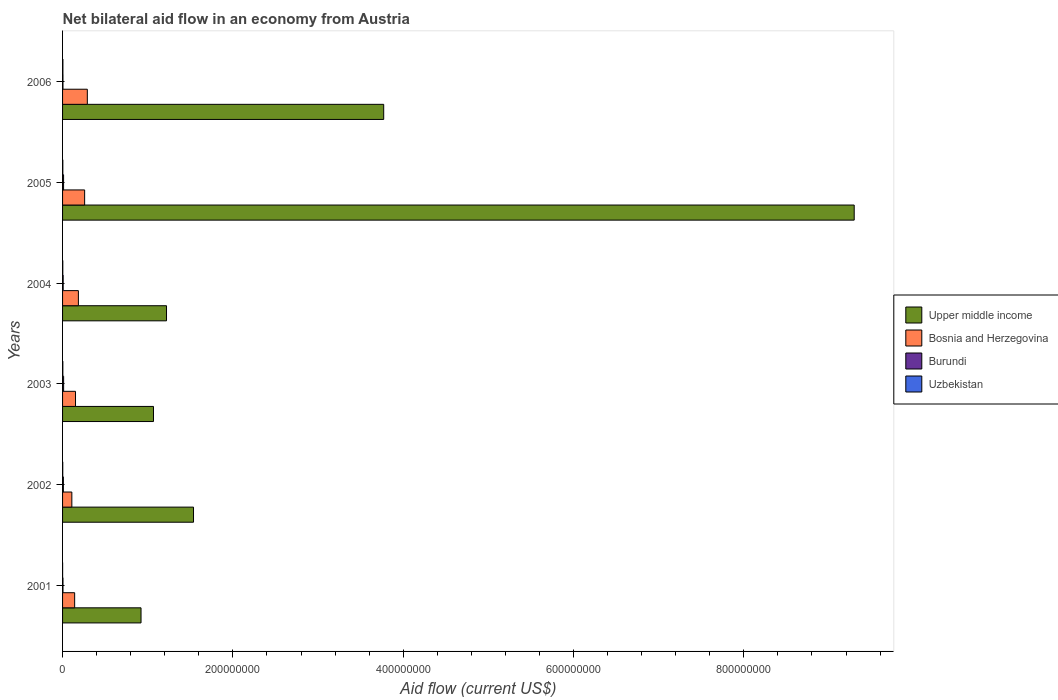How many groups of bars are there?
Make the answer very short. 6. How many bars are there on the 6th tick from the top?
Provide a succinct answer. 4. What is the label of the 6th group of bars from the top?
Offer a very short reply. 2001. In how many cases, is the number of bars for a given year not equal to the number of legend labels?
Your answer should be very brief. 0. What is the net bilateral aid flow in Upper middle income in 2002?
Offer a very short reply. 1.54e+08. Across all years, what is the maximum net bilateral aid flow in Bosnia and Herzegovina?
Your response must be concise. 2.91e+07. In which year was the net bilateral aid flow in Burundi maximum?
Ensure brevity in your answer.  2003. In which year was the net bilateral aid flow in Upper middle income minimum?
Provide a short and direct response. 2001. What is the total net bilateral aid flow in Bosnia and Herzegovina in the graph?
Your answer should be very brief. 1.14e+08. What is the difference between the net bilateral aid flow in Uzbekistan in 2004 and the net bilateral aid flow in Burundi in 2003?
Your answer should be very brief. -9.70e+05. What is the average net bilateral aid flow in Uzbekistan per year?
Ensure brevity in your answer.  2.58e+05. In the year 2002, what is the difference between the net bilateral aid flow in Uzbekistan and net bilateral aid flow in Burundi?
Make the answer very short. -7.40e+05. Is the net bilateral aid flow in Bosnia and Herzegovina in 2004 less than that in 2005?
Your answer should be compact. Yes. Is the difference between the net bilateral aid flow in Uzbekistan in 2001 and 2004 greater than the difference between the net bilateral aid flow in Burundi in 2001 and 2004?
Your answer should be very brief. Yes. What is the difference between the highest and the second highest net bilateral aid flow in Bosnia and Herzegovina?
Your answer should be very brief. 3.14e+06. What is the difference between the highest and the lowest net bilateral aid flow in Upper middle income?
Keep it short and to the point. 8.37e+08. Is the sum of the net bilateral aid flow in Upper middle income in 2002 and 2003 greater than the maximum net bilateral aid flow in Uzbekistan across all years?
Your answer should be very brief. Yes. What does the 1st bar from the top in 2005 represents?
Your answer should be compact. Uzbekistan. What does the 3rd bar from the bottom in 2005 represents?
Give a very brief answer. Burundi. Is it the case that in every year, the sum of the net bilateral aid flow in Bosnia and Herzegovina and net bilateral aid flow in Upper middle income is greater than the net bilateral aid flow in Uzbekistan?
Keep it short and to the point. Yes. How many years are there in the graph?
Make the answer very short. 6. Where does the legend appear in the graph?
Ensure brevity in your answer.  Center right. How many legend labels are there?
Your answer should be very brief. 4. What is the title of the graph?
Your answer should be very brief. Net bilateral aid flow in an economy from Austria. Does "Sudan" appear as one of the legend labels in the graph?
Provide a short and direct response. No. What is the label or title of the Y-axis?
Provide a short and direct response. Years. What is the Aid flow (current US$) in Upper middle income in 2001?
Your answer should be compact. 9.21e+07. What is the Aid flow (current US$) of Bosnia and Herzegovina in 2001?
Ensure brevity in your answer.  1.42e+07. What is the Aid flow (current US$) in Burundi in 2001?
Make the answer very short. 4.90e+05. What is the Aid flow (current US$) in Upper middle income in 2002?
Give a very brief answer. 1.54e+08. What is the Aid flow (current US$) in Bosnia and Herzegovina in 2002?
Your response must be concise. 1.09e+07. What is the Aid flow (current US$) of Burundi in 2002?
Your response must be concise. 9.50e+05. What is the Aid flow (current US$) in Uzbekistan in 2002?
Offer a very short reply. 2.10e+05. What is the Aid flow (current US$) in Upper middle income in 2003?
Make the answer very short. 1.07e+08. What is the Aid flow (current US$) of Bosnia and Herzegovina in 2003?
Ensure brevity in your answer.  1.52e+07. What is the Aid flow (current US$) in Burundi in 2003?
Your answer should be compact. 1.24e+06. What is the Aid flow (current US$) of Uzbekistan in 2003?
Keep it short and to the point. 3.20e+05. What is the Aid flow (current US$) of Upper middle income in 2004?
Ensure brevity in your answer.  1.22e+08. What is the Aid flow (current US$) of Bosnia and Herzegovina in 2004?
Your answer should be very brief. 1.86e+07. What is the Aid flow (current US$) of Burundi in 2004?
Ensure brevity in your answer.  7.20e+05. What is the Aid flow (current US$) in Uzbekistan in 2004?
Give a very brief answer. 2.70e+05. What is the Aid flow (current US$) in Upper middle income in 2005?
Make the answer very short. 9.30e+08. What is the Aid flow (current US$) in Bosnia and Herzegovina in 2005?
Your answer should be compact. 2.59e+07. What is the Aid flow (current US$) of Burundi in 2005?
Make the answer very short. 1.18e+06. What is the Aid flow (current US$) in Upper middle income in 2006?
Provide a succinct answer. 3.77e+08. What is the Aid flow (current US$) in Bosnia and Herzegovina in 2006?
Provide a short and direct response. 2.91e+07. What is the Aid flow (current US$) in Uzbekistan in 2006?
Give a very brief answer. 4.00e+05. Across all years, what is the maximum Aid flow (current US$) in Upper middle income?
Offer a terse response. 9.30e+08. Across all years, what is the maximum Aid flow (current US$) in Bosnia and Herzegovina?
Ensure brevity in your answer.  2.91e+07. Across all years, what is the maximum Aid flow (current US$) of Burundi?
Ensure brevity in your answer.  1.24e+06. Across all years, what is the maximum Aid flow (current US$) of Uzbekistan?
Give a very brief answer. 4.00e+05. Across all years, what is the minimum Aid flow (current US$) of Upper middle income?
Make the answer very short. 9.21e+07. Across all years, what is the minimum Aid flow (current US$) in Bosnia and Herzegovina?
Your answer should be compact. 1.09e+07. Across all years, what is the minimum Aid flow (current US$) in Burundi?
Your answer should be compact. 4.80e+05. Across all years, what is the minimum Aid flow (current US$) of Uzbekistan?
Your answer should be compact. 5.00e+04. What is the total Aid flow (current US$) of Upper middle income in the graph?
Provide a succinct answer. 1.78e+09. What is the total Aid flow (current US$) of Bosnia and Herzegovina in the graph?
Your response must be concise. 1.14e+08. What is the total Aid flow (current US$) in Burundi in the graph?
Ensure brevity in your answer.  5.06e+06. What is the total Aid flow (current US$) of Uzbekistan in the graph?
Make the answer very short. 1.55e+06. What is the difference between the Aid flow (current US$) of Upper middle income in 2001 and that in 2002?
Provide a succinct answer. -6.16e+07. What is the difference between the Aid flow (current US$) of Bosnia and Herzegovina in 2001 and that in 2002?
Offer a terse response. 3.30e+06. What is the difference between the Aid flow (current US$) in Burundi in 2001 and that in 2002?
Your answer should be compact. -4.60e+05. What is the difference between the Aid flow (current US$) in Upper middle income in 2001 and that in 2003?
Provide a short and direct response. -1.46e+07. What is the difference between the Aid flow (current US$) in Bosnia and Herzegovina in 2001 and that in 2003?
Ensure brevity in your answer.  -1.01e+06. What is the difference between the Aid flow (current US$) in Burundi in 2001 and that in 2003?
Ensure brevity in your answer.  -7.50e+05. What is the difference between the Aid flow (current US$) in Uzbekistan in 2001 and that in 2003?
Ensure brevity in your answer.  -2.70e+05. What is the difference between the Aid flow (current US$) in Upper middle income in 2001 and that in 2004?
Make the answer very short. -2.99e+07. What is the difference between the Aid flow (current US$) in Bosnia and Herzegovina in 2001 and that in 2004?
Your response must be concise. -4.40e+06. What is the difference between the Aid flow (current US$) of Upper middle income in 2001 and that in 2005?
Provide a succinct answer. -8.37e+08. What is the difference between the Aid flow (current US$) of Bosnia and Herzegovina in 2001 and that in 2005?
Keep it short and to the point. -1.17e+07. What is the difference between the Aid flow (current US$) of Burundi in 2001 and that in 2005?
Make the answer very short. -6.90e+05. What is the difference between the Aid flow (current US$) in Upper middle income in 2001 and that in 2006?
Your answer should be compact. -2.85e+08. What is the difference between the Aid flow (current US$) of Bosnia and Herzegovina in 2001 and that in 2006?
Your response must be concise. -1.49e+07. What is the difference between the Aid flow (current US$) in Uzbekistan in 2001 and that in 2006?
Ensure brevity in your answer.  -3.50e+05. What is the difference between the Aid flow (current US$) of Upper middle income in 2002 and that in 2003?
Offer a very short reply. 4.70e+07. What is the difference between the Aid flow (current US$) of Bosnia and Herzegovina in 2002 and that in 2003?
Your response must be concise. -4.31e+06. What is the difference between the Aid flow (current US$) in Burundi in 2002 and that in 2003?
Offer a very short reply. -2.90e+05. What is the difference between the Aid flow (current US$) in Upper middle income in 2002 and that in 2004?
Ensure brevity in your answer.  3.17e+07. What is the difference between the Aid flow (current US$) of Bosnia and Herzegovina in 2002 and that in 2004?
Make the answer very short. -7.70e+06. What is the difference between the Aid flow (current US$) of Burundi in 2002 and that in 2004?
Make the answer very short. 2.30e+05. What is the difference between the Aid flow (current US$) in Upper middle income in 2002 and that in 2005?
Give a very brief answer. -7.76e+08. What is the difference between the Aid flow (current US$) in Bosnia and Herzegovina in 2002 and that in 2005?
Your answer should be compact. -1.50e+07. What is the difference between the Aid flow (current US$) of Upper middle income in 2002 and that in 2006?
Your response must be concise. -2.23e+08. What is the difference between the Aid flow (current US$) in Bosnia and Herzegovina in 2002 and that in 2006?
Ensure brevity in your answer.  -1.82e+07. What is the difference between the Aid flow (current US$) in Burundi in 2002 and that in 2006?
Keep it short and to the point. 4.70e+05. What is the difference between the Aid flow (current US$) of Uzbekistan in 2002 and that in 2006?
Provide a succinct answer. -1.90e+05. What is the difference between the Aid flow (current US$) of Upper middle income in 2003 and that in 2004?
Make the answer very short. -1.53e+07. What is the difference between the Aid flow (current US$) in Bosnia and Herzegovina in 2003 and that in 2004?
Offer a very short reply. -3.39e+06. What is the difference between the Aid flow (current US$) of Burundi in 2003 and that in 2004?
Your response must be concise. 5.20e+05. What is the difference between the Aid flow (current US$) in Uzbekistan in 2003 and that in 2004?
Offer a very short reply. 5.00e+04. What is the difference between the Aid flow (current US$) of Upper middle income in 2003 and that in 2005?
Provide a short and direct response. -8.23e+08. What is the difference between the Aid flow (current US$) in Bosnia and Herzegovina in 2003 and that in 2005?
Keep it short and to the point. -1.07e+07. What is the difference between the Aid flow (current US$) of Upper middle income in 2003 and that in 2006?
Make the answer very short. -2.70e+08. What is the difference between the Aid flow (current US$) in Bosnia and Herzegovina in 2003 and that in 2006?
Your answer should be compact. -1.39e+07. What is the difference between the Aid flow (current US$) of Burundi in 2003 and that in 2006?
Your response must be concise. 7.60e+05. What is the difference between the Aid flow (current US$) of Upper middle income in 2004 and that in 2005?
Your answer should be very brief. -8.08e+08. What is the difference between the Aid flow (current US$) in Bosnia and Herzegovina in 2004 and that in 2005?
Provide a short and direct response. -7.34e+06. What is the difference between the Aid flow (current US$) in Burundi in 2004 and that in 2005?
Your answer should be very brief. -4.60e+05. What is the difference between the Aid flow (current US$) of Uzbekistan in 2004 and that in 2005?
Your response must be concise. -3.00e+04. What is the difference between the Aid flow (current US$) of Upper middle income in 2004 and that in 2006?
Offer a very short reply. -2.55e+08. What is the difference between the Aid flow (current US$) of Bosnia and Herzegovina in 2004 and that in 2006?
Provide a short and direct response. -1.05e+07. What is the difference between the Aid flow (current US$) of Burundi in 2004 and that in 2006?
Your answer should be very brief. 2.40e+05. What is the difference between the Aid flow (current US$) of Upper middle income in 2005 and that in 2006?
Ensure brevity in your answer.  5.52e+08. What is the difference between the Aid flow (current US$) of Bosnia and Herzegovina in 2005 and that in 2006?
Give a very brief answer. -3.14e+06. What is the difference between the Aid flow (current US$) of Upper middle income in 2001 and the Aid flow (current US$) of Bosnia and Herzegovina in 2002?
Provide a succinct answer. 8.12e+07. What is the difference between the Aid flow (current US$) of Upper middle income in 2001 and the Aid flow (current US$) of Burundi in 2002?
Ensure brevity in your answer.  9.12e+07. What is the difference between the Aid flow (current US$) in Upper middle income in 2001 and the Aid flow (current US$) in Uzbekistan in 2002?
Ensure brevity in your answer.  9.19e+07. What is the difference between the Aid flow (current US$) of Bosnia and Herzegovina in 2001 and the Aid flow (current US$) of Burundi in 2002?
Ensure brevity in your answer.  1.32e+07. What is the difference between the Aid flow (current US$) in Bosnia and Herzegovina in 2001 and the Aid flow (current US$) in Uzbekistan in 2002?
Ensure brevity in your answer.  1.40e+07. What is the difference between the Aid flow (current US$) of Burundi in 2001 and the Aid flow (current US$) of Uzbekistan in 2002?
Keep it short and to the point. 2.80e+05. What is the difference between the Aid flow (current US$) in Upper middle income in 2001 and the Aid flow (current US$) in Bosnia and Herzegovina in 2003?
Your answer should be compact. 7.69e+07. What is the difference between the Aid flow (current US$) of Upper middle income in 2001 and the Aid flow (current US$) of Burundi in 2003?
Offer a very short reply. 9.09e+07. What is the difference between the Aid flow (current US$) in Upper middle income in 2001 and the Aid flow (current US$) in Uzbekistan in 2003?
Your answer should be very brief. 9.18e+07. What is the difference between the Aid flow (current US$) of Bosnia and Herzegovina in 2001 and the Aid flow (current US$) of Burundi in 2003?
Provide a succinct answer. 1.30e+07. What is the difference between the Aid flow (current US$) of Bosnia and Herzegovina in 2001 and the Aid flow (current US$) of Uzbekistan in 2003?
Make the answer very short. 1.39e+07. What is the difference between the Aid flow (current US$) in Upper middle income in 2001 and the Aid flow (current US$) in Bosnia and Herzegovina in 2004?
Provide a short and direct response. 7.36e+07. What is the difference between the Aid flow (current US$) in Upper middle income in 2001 and the Aid flow (current US$) in Burundi in 2004?
Provide a succinct answer. 9.14e+07. What is the difference between the Aid flow (current US$) in Upper middle income in 2001 and the Aid flow (current US$) in Uzbekistan in 2004?
Make the answer very short. 9.19e+07. What is the difference between the Aid flow (current US$) in Bosnia and Herzegovina in 2001 and the Aid flow (current US$) in Burundi in 2004?
Your response must be concise. 1.35e+07. What is the difference between the Aid flow (current US$) in Bosnia and Herzegovina in 2001 and the Aid flow (current US$) in Uzbekistan in 2004?
Offer a very short reply. 1.39e+07. What is the difference between the Aid flow (current US$) of Upper middle income in 2001 and the Aid flow (current US$) of Bosnia and Herzegovina in 2005?
Your response must be concise. 6.62e+07. What is the difference between the Aid flow (current US$) in Upper middle income in 2001 and the Aid flow (current US$) in Burundi in 2005?
Offer a very short reply. 9.10e+07. What is the difference between the Aid flow (current US$) in Upper middle income in 2001 and the Aid flow (current US$) in Uzbekistan in 2005?
Give a very brief answer. 9.18e+07. What is the difference between the Aid flow (current US$) in Bosnia and Herzegovina in 2001 and the Aid flow (current US$) in Burundi in 2005?
Your answer should be compact. 1.30e+07. What is the difference between the Aid flow (current US$) of Bosnia and Herzegovina in 2001 and the Aid flow (current US$) of Uzbekistan in 2005?
Keep it short and to the point. 1.39e+07. What is the difference between the Aid flow (current US$) in Burundi in 2001 and the Aid flow (current US$) in Uzbekistan in 2005?
Provide a succinct answer. 1.90e+05. What is the difference between the Aid flow (current US$) of Upper middle income in 2001 and the Aid flow (current US$) of Bosnia and Herzegovina in 2006?
Ensure brevity in your answer.  6.31e+07. What is the difference between the Aid flow (current US$) of Upper middle income in 2001 and the Aid flow (current US$) of Burundi in 2006?
Make the answer very short. 9.17e+07. What is the difference between the Aid flow (current US$) in Upper middle income in 2001 and the Aid flow (current US$) in Uzbekistan in 2006?
Offer a terse response. 9.17e+07. What is the difference between the Aid flow (current US$) in Bosnia and Herzegovina in 2001 and the Aid flow (current US$) in Burundi in 2006?
Give a very brief answer. 1.37e+07. What is the difference between the Aid flow (current US$) in Bosnia and Herzegovina in 2001 and the Aid flow (current US$) in Uzbekistan in 2006?
Offer a very short reply. 1.38e+07. What is the difference between the Aid flow (current US$) in Upper middle income in 2002 and the Aid flow (current US$) in Bosnia and Herzegovina in 2003?
Give a very brief answer. 1.39e+08. What is the difference between the Aid flow (current US$) in Upper middle income in 2002 and the Aid flow (current US$) in Burundi in 2003?
Provide a short and direct response. 1.53e+08. What is the difference between the Aid flow (current US$) of Upper middle income in 2002 and the Aid flow (current US$) of Uzbekistan in 2003?
Keep it short and to the point. 1.53e+08. What is the difference between the Aid flow (current US$) in Bosnia and Herzegovina in 2002 and the Aid flow (current US$) in Burundi in 2003?
Your answer should be compact. 9.65e+06. What is the difference between the Aid flow (current US$) in Bosnia and Herzegovina in 2002 and the Aid flow (current US$) in Uzbekistan in 2003?
Offer a terse response. 1.06e+07. What is the difference between the Aid flow (current US$) of Burundi in 2002 and the Aid flow (current US$) of Uzbekistan in 2003?
Your answer should be compact. 6.30e+05. What is the difference between the Aid flow (current US$) in Upper middle income in 2002 and the Aid flow (current US$) in Bosnia and Herzegovina in 2004?
Offer a very short reply. 1.35e+08. What is the difference between the Aid flow (current US$) of Upper middle income in 2002 and the Aid flow (current US$) of Burundi in 2004?
Give a very brief answer. 1.53e+08. What is the difference between the Aid flow (current US$) in Upper middle income in 2002 and the Aid flow (current US$) in Uzbekistan in 2004?
Give a very brief answer. 1.54e+08. What is the difference between the Aid flow (current US$) of Bosnia and Herzegovina in 2002 and the Aid flow (current US$) of Burundi in 2004?
Offer a terse response. 1.02e+07. What is the difference between the Aid flow (current US$) in Bosnia and Herzegovina in 2002 and the Aid flow (current US$) in Uzbekistan in 2004?
Give a very brief answer. 1.06e+07. What is the difference between the Aid flow (current US$) in Burundi in 2002 and the Aid flow (current US$) in Uzbekistan in 2004?
Keep it short and to the point. 6.80e+05. What is the difference between the Aid flow (current US$) in Upper middle income in 2002 and the Aid flow (current US$) in Bosnia and Herzegovina in 2005?
Ensure brevity in your answer.  1.28e+08. What is the difference between the Aid flow (current US$) of Upper middle income in 2002 and the Aid flow (current US$) of Burundi in 2005?
Provide a succinct answer. 1.53e+08. What is the difference between the Aid flow (current US$) in Upper middle income in 2002 and the Aid flow (current US$) in Uzbekistan in 2005?
Give a very brief answer. 1.53e+08. What is the difference between the Aid flow (current US$) in Bosnia and Herzegovina in 2002 and the Aid flow (current US$) in Burundi in 2005?
Make the answer very short. 9.71e+06. What is the difference between the Aid flow (current US$) in Bosnia and Herzegovina in 2002 and the Aid flow (current US$) in Uzbekistan in 2005?
Provide a short and direct response. 1.06e+07. What is the difference between the Aid flow (current US$) in Burundi in 2002 and the Aid flow (current US$) in Uzbekistan in 2005?
Keep it short and to the point. 6.50e+05. What is the difference between the Aid flow (current US$) in Upper middle income in 2002 and the Aid flow (current US$) in Bosnia and Herzegovina in 2006?
Offer a terse response. 1.25e+08. What is the difference between the Aid flow (current US$) in Upper middle income in 2002 and the Aid flow (current US$) in Burundi in 2006?
Your answer should be very brief. 1.53e+08. What is the difference between the Aid flow (current US$) of Upper middle income in 2002 and the Aid flow (current US$) of Uzbekistan in 2006?
Offer a terse response. 1.53e+08. What is the difference between the Aid flow (current US$) of Bosnia and Herzegovina in 2002 and the Aid flow (current US$) of Burundi in 2006?
Provide a succinct answer. 1.04e+07. What is the difference between the Aid flow (current US$) in Bosnia and Herzegovina in 2002 and the Aid flow (current US$) in Uzbekistan in 2006?
Ensure brevity in your answer.  1.05e+07. What is the difference between the Aid flow (current US$) of Upper middle income in 2003 and the Aid flow (current US$) of Bosnia and Herzegovina in 2004?
Keep it short and to the point. 8.82e+07. What is the difference between the Aid flow (current US$) of Upper middle income in 2003 and the Aid flow (current US$) of Burundi in 2004?
Your response must be concise. 1.06e+08. What is the difference between the Aid flow (current US$) of Upper middle income in 2003 and the Aid flow (current US$) of Uzbekistan in 2004?
Your response must be concise. 1.06e+08. What is the difference between the Aid flow (current US$) of Bosnia and Herzegovina in 2003 and the Aid flow (current US$) of Burundi in 2004?
Your answer should be very brief. 1.45e+07. What is the difference between the Aid flow (current US$) in Bosnia and Herzegovina in 2003 and the Aid flow (current US$) in Uzbekistan in 2004?
Your answer should be compact. 1.49e+07. What is the difference between the Aid flow (current US$) in Burundi in 2003 and the Aid flow (current US$) in Uzbekistan in 2004?
Your answer should be very brief. 9.70e+05. What is the difference between the Aid flow (current US$) of Upper middle income in 2003 and the Aid flow (current US$) of Bosnia and Herzegovina in 2005?
Offer a very short reply. 8.08e+07. What is the difference between the Aid flow (current US$) of Upper middle income in 2003 and the Aid flow (current US$) of Burundi in 2005?
Make the answer very short. 1.06e+08. What is the difference between the Aid flow (current US$) of Upper middle income in 2003 and the Aid flow (current US$) of Uzbekistan in 2005?
Keep it short and to the point. 1.06e+08. What is the difference between the Aid flow (current US$) in Bosnia and Herzegovina in 2003 and the Aid flow (current US$) in Burundi in 2005?
Offer a terse response. 1.40e+07. What is the difference between the Aid flow (current US$) of Bosnia and Herzegovina in 2003 and the Aid flow (current US$) of Uzbekistan in 2005?
Ensure brevity in your answer.  1.49e+07. What is the difference between the Aid flow (current US$) of Burundi in 2003 and the Aid flow (current US$) of Uzbekistan in 2005?
Provide a short and direct response. 9.40e+05. What is the difference between the Aid flow (current US$) of Upper middle income in 2003 and the Aid flow (current US$) of Bosnia and Herzegovina in 2006?
Provide a succinct answer. 7.77e+07. What is the difference between the Aid flow (current US$) in Upper middle income in 2003 and the Aid flow (current US$) in Burundi in 2006?
Your answer should be very brief. 1.06e+08. What is the difference between the Aid flow (current US$) in Upper middle income in 2003 and the Aid flow (current US$) in Uzbekistan in 2006?
Your answer should be very brief. 1.06e+08. What is the difference between the Aid flow (current US$) of Bosnia and Herzegovina in 2003 and the Aid flow (current US$) of Burundi in 2006?
Offer a terse response. 1.47e+07. What is the difference between the Aid flow (current US$) in Bosnia and Herzegovina in 2003 and the Aid flow (current US$) in Uzbekistan in 2006?
Your answer should be very brief. 1.48e+07. What is the difference between the Aid flow (current US$) of Burundi in 2003 and the Aid flow (current US$) of Uzbekistan in 2006?
Offer a very short reply. 8.40e+05. What is the difference between the Aid flow (current US$) in Upper middle income in 2004 and the Aid flow (current US$) in Bosnia and Herzegovina in 2005?
Make the answer very short. 9.61e+07. What is the difference between the Aid flow (current US$) of Upper middle income in 2004 and the Aid flow (current US$) of Burundi in 2005?
Give a very brief answer. 1.21e+08. What is the difference between the Aid flow (current US$) in Upper middle income in 2004 and the Aid flow (current US$) in Uzbekistan in 2005?
Ensure brevity in your answer.  1.22e+08. What is the difference between the Aid flow (current US$) of Bosnia and Herzegovina in 2004 and the Aid flow (current US$) of Burundi in 2005?
Ensure brevity in your answer.  1.74e+07. What is the difference between the Aid flow (current US$) of Bosnia and Herzegovina in 2004 and the Aid flow (current US$) of Uzbekistan in 2005?
Offer a terse response. 1.83e+07. What is the difference between the Aid flow (current US$) of Burundi in 2004 and the Aid flow (current US$) of Uzbekistan in 2005?
Give a very brief answer. 4.20e+05. What is the difference between the Aid flow (current US$) of Upper middle income in 2004 and the Aid flow (current US$) of Bosnia and Herzegovina in 2006?
Offer a very short reply. 9.30e+07. What is the difference between the Aid flow (current US$) of Upper middle income in 2004 and the Aid flow (current US$) of Burundi in 2006?
Keep it short and to the point. 1.22e+08. What is the difference between the Aid flow (current US$) in Upper middle income in 2004 and the Aid flow (current US$) in Uzbekistan in 2006?
Provide a succinct answer. 1.22e+08. What is the difference between the Aid flow (current US$) in Bosnia and Herzegovina in 2004 and the Aid flow (current US$) in Burundi in 2006?
Your answer should be compact. 1.81e+07. What is the difference between the Aid flow (current US$) in Bosnia and Herzegovina in 2004 and the Aid flow (current US$) in Uzbekistan in 2006?
Ensure brevity in your answer.  1.82e+07. What is the difference between the Aid flow (current US$) of Upper middle income in 2005 and the Aid flow (current US$) of Bosnia and Herzegovina in 2006?
Make the answer very short. 9.01e+08. What is the difference between the Aid flow (current US$) of Upper middle income in 2005 and the Aid flow (current US$) of Burundi in 2006?
Offer a terse response. 9.29e+08. What is the difference between the Aid flow (current US$) in Upper middle income in 2005 and the Aid flow (current US$) in Uzbekistan in 2006?
Offer a very short reply. 9.29e+08. What is the difference between the Aid flow (current US$) in Bosnia and Herzegovina in 2005 and the Aid flow (current US$) in Burundi in 2006?
Ensure brevity in your answer.  2.54e+07. What is the difference between the Aid flow (current US$) in Bosnia and Herzegovina in 2005 and the Aid flow (current US$) in Uzbekistan in 2006?
Give a very brief answer. 2.55e+07. What is the difference between the Aid flow (current US$) in Burundi in 2005 and the Aid flow (current US$) in Uzbekistan in 2006?
Your response must be concise. 7.80e+05. What is the average Aid flow (current US$) in Upper middle income per year?
Offer a very short reply. 2.97e+08. What is the average Aid flow (current US$) in Bosnia and Herzegovina per year?
Your answer should be compact. 1.90e+07. What is the average Aid flow (current US$) in Burundi per year?
Your answer should be compact. 8.43e+05. What is the average Aid flow (current US$) of Uzbekistan per year?
Your answer should be compact. 2.58e+05. In the year 2001, what is the difference between the Aid flow (current US$) in Upper middle income and Aid flow (current US$) in Bosnia and Herzegovina?
Give a very brief answer. 7.80e+07. In the year 2001, what is the difference between the Aid flow (current US$) in Upper middle income and Aid flow (current US$) in Burundi?
Give a very brief answer. 9.16e+07. In the year 2001, what is the difference between the Aid flow (current US$) of Upper middle income and Aid flow (current US$) of Uzbekistan?
Your answer should be compact. 9.21e+07. In the year 2001, what is the difference between the Aid flow (current US$) of Bosnia and Herzegovina and Aid flow (current US$) of Burundi?
Your answer should be very brief. 1.37e+07. In the year 2001, what is the difference between the Aid flow (current US$) in Bosnia and Herzegovina and Aid flow (current US$) in Uzbekistan?
Your answer should be very brief. 1.41e+07. In the year 2001, what is the difference between the Aid flow (current US$) in Burundi and Aid flow (current US$) in Uzbekistan?
Give a very brief answer. 4.40e+05. In the year 2002, what is the difference between the Aid flow (current US$) in Upper middle income and Aid flow (current US$) in Bosnia and Herzegovina?
Provide a succinct answer. 1.43e+08. In the year 2002, what is the difference between the Aid flow (current US$) in Upper middle income and Aid flow (current US$) in Burundi?
Your answer should be very brief. 1.53e+08. In the year 2002, what is the difference between the Aid flow (current US$) in Upper middle income and Aid flow (current US$) in Uzbekistan?
Your answer should be compact. 1.54e+08. In the year 2002, what is the difference between the Aid flow (current US$) in Bosnia and Herzegovina and Aid flow (current US$) in Burundi?
Ensure brevity in your answer.  9.94e+06. In the year 2002, what is the difference between the Aid flow (current US$) in Bosnia and Herzegovina and Aid flow (current US$) in Uzbekistan?
Your answer should be very brief. 1.07e+07. In the year 2002, what is the difference between the Aid flow (current US$) of Burundi and Aid flow (current US$) of Uzbekistan?
Provide a succinct answer. 7.40e+05. In the year 2003, what is the difference between the Aid flow (current US$) of Upper middle income and Aid flow (current US$) of Bosnia and Herzegovina?
Your response must be concise. 9.16e+07. In the year 2003, what is the difference between the Aid flow (current US$) of Upper middle income and Aid flow (current US$) of Burundi?
Your answer should be very brief. 1.06e+08. In the year 2003, what is the difference between the Aid flow (current US$) of Upper middle income and Aid flow (current US$) of Uzbekistan?
Offer a very short reply. 1.06e+08. In the year 2003, what is the difference between the Aid flow (current US$) in Bosnia and Herzegovina and Aid flow (current US$) in Burundi?
Your answer should be compact. 1.40e+07. In the year 2003, what is the difference between the Aid flow (current US$) in Bosnia and Herzegovina and Aid flow (current US$) in Uzbekistan?
Your answer should be compact. 1.49e+07. In the year 2003, what is the difference between the Aid flow (current US$) in Burundi and Aid flow (current US$) in Uzbekistan?
Your response must be concise. 9.20e+05. In the year 2004, what is the difference between the Aid flow (current US$) in Upper middle income and Aid flow (current US$) in Bosnia and Herzegovina?
Give a very brief answer. 1.03e+08. In the year 2004, what is the difference between the Aid flow (current US$) of Upper middle income and Aid flow (current US$) of Burundi?
Your response must be concise. 1.21e+08. In the year 2004, what is the difference between the Aid flow (current US$) of Upper middle income and Aid flow (current US$) of Uzbekistan?
Your answer should be compact. 1.22e+08. In the year 2004, what is the difference between the Aid flow (current US$) in Bosnia and Herzegovina and Aid flow (current US$) in Burundi?
Offer a terse response. 1.79e+07. In the year 2004, what is the difference between the Aid flow (current US$) of Bosnia and Herzegovina and Aid flow (current US$) of Uzbekistan?
Provide a short and direct response. 1.83e+07. In the year 2005, what is the difference between the Aid flow (current US$) in Upper middle income and Aid flow (current US$) in Bosnia and Herzegovina?
Offer a very short reply. 9.04e+08. In the year 2005, what is the difference between the Aid flow (current US$) of Upper middle income and Aid flow (current US$) of Burundi?
Offer a very short reply. 9.28e+08. In the year 2005, what is the difference between the Aid flow (current US$) of Upper middle income and Aid flow (current US$) of Uzbekistan?
Ensure brevity in your answer.  9.29e+08. In the year 2005, what is the difference between the Aid flow (current US$) in Bosnia and Herzegovina and Aid flow (current US$) in Burundi?
Give a very brief answer. 2.48e+07. In the year 2005, what is the difference between the Aid flow (current US$) in Bosnia and Herzegovina and Aid flow (current US$) in Uzbekistan?
Make the answer very short. 2.56e+07. In the year 2005, what is the difference between the Aid flow (current US$) of Burundi and Aid flow (current US$) of Uzbekistan?
Your answer should be very brief. 8.80e+05. In the year 2006, what is the difference between the Aid flow (current US$) of Upper middle income and Aid flow (current US$) of Bosnia and Herzegovina?
Your answer should be very brief. 3.48e+08. In the year 2006, what is the difference between the Aid flow (current US$) of Upper middle income and Aid flow (current US$) of Burundi?
Make the answer very short. 3.77e+08. In the year 2006, what is the difference between the Aid flow (current US$) in Upper middle income and Aid flow (current US$) in Uzbekistan?
Make the answer very short. 3.77e+08. In the year 2006, what is the difference between the Aid flow (current US$) in Bosnia and Herzegovina and Aid flow (current US$) in Burundi?
Provide a short and direct response. 2.86e+07. In the year 2006, what is the difference between the Aid flow (current US$) in Bosnia and Herzegovina and Aid flow (current US$) in Uzbekistan?
Your answer should be compact. 2.87e+07. In the year 2006, what is the difference between the Aid flow (current US$) of Burundi and Aid flow (current US$) of Uzbekistan?
Your answer should be compact. 8.00e+04. What is the ratio of the Aid flow (current US$) of Upper middle income in 2001 to that in 2002?
Your answer should be very brief. 0.6. What is the ratio of the Aid flow (current US$) in Bosnia and Herzegovina in 2001 to that in 2002?
Your answer should be compact. 1.3. What is the ratio of the Aid flow (current US$) of Burundi in 2001 to that in 2002?
Your response must be concise. 0.52. What is the ratio of the Aid flow (current US$) in Uzbekistan in 2001 to that in 2002?
Your answer should be very brief. 0.24. What is the ratio of the Aid flow (current US$) in Upper middle income in 2001 to that in 2003?
Your response must be concise. 0.86. What is the ratio of the Aid flow (current US$) in Bosnia and Herzegovina in 2001 to that in 2003?
Offer a terse response. 0.93. What is the ratio of the Aid flow (current US$) in Burundi in 2001 to that in 2003?
Give a very brief answer. 0.4. What is the ratio of the Aid flow (current US$) in Uzbekistan in 2001 to that in 2003?
Your answer should be very brief. 0.16. What is the ratio of the Aid flow (current US$) of Upper middle income in 2001 to that in 2004?
Provide a short and direct response. 0.75. What is the ratio of the Aid flow (current US$) in Bosnia and Herzegovina in 2001 to that in 2004?
Keep it short and to the point. 0.76. What is the ratio of the Aid flow (current US$) in Burundi in 2001 to that in 2004?
Your answer should be very brief. 0.68. What is the ratio of the Aid flow (current US$) of Uzbekistan in 2001 to that in 2004?
Offer a terse response. 0.19. What is the ratio of the Aid flow (current US$) in Upper middle income in 2001 to that in 2005?
Your response must be concise. 0.1. What is the ratio of the Aid flow (current US$) of Bosnia and Herzegovina in 2001 to that in 2005?
Ensure brevity in your answer.  0.55. What is the ratio of the Aid flow (current US$) of Burundi in 2001 to that in 2005?
Offer a terse response. 0.42. What is the ratio of the Aid flow (current US$) of Upper middle income in 2001 to that in 2006?
Ensure brevity in your answer.  0.24. What is the ratio of the Aid flow (current US$) of Bosnia and Herzegovina in 2001 to that in 2006?
Keep it short and to the point. 0.49. What is the ratio of the Aid flow (current US$) in Burundi in 2001 to that in 2006?
Offer a very short reply. 1.02. What is the ratio of the Aid flow (current US$) in Upper middle income in 2002 to that in 2003?
Provide a succinct answer. 1.44. What is the ratio of the Aid flow (current US$) of Bosnia and Herzegovina in 2002 to that in 2003?
Give a very brief answer. 0.72. What is the ratio of the Aid flow (current US$) in Burundi in 2002 to that in 2003?
Your answer should be compact. 0.77. What is the ratio of the Aid flow (current US$) in Uzbekistan in 2002 to that in 2003?
Offer a very short reply. 0.66. What is the ratio of the Aid flow (current US$) in Upper middle income in 2002 to that in 2004?
Give a very brief answer. 1.26. What is the ratio of the Aid flow (current US$) in Bosnia and Herzegovina in 2002 to that in 2004?
Provide a short and direct response. 0.59. What is the ratio of the Aid flow (current US$) of Burundi in 2002 to that in 2004?
Make the answer very short. 1.32. What is the ratio of the Aid flow (current US$) of Uzbekistan in 2002 to that in 2004?
Provide a succinct answer. 0.78. What is the ratio of the Aid flow (current US$) in Upper middle income in 2002 to that in 2005?
Give a very brief answer. 0.17. What is the ratio of the Aid flow (current US$) in Bosnia and Herzegovina in 2002 to that in 2005?
Offer a very short reply. 0.42. What is the ratio of the Aid flow (current US$) of Burundi in 2002 to that in 2005?
Your answer should be compact. 0.81. What is the ratio of the Aid flow (current US$) in Uzbekistan in 2002 to that in 2005?
Keep it short and to the point. 0.7. What is the ratio of the Aid flow (current US$) of Upper middle income in 2002 to that in 2006?
Your response must be concise. 0.41. What is the ratio of the Aid flow (current US$) in Bosnia and Herzegovina in 2002 to that in 2006?
Ensure brevity in your answer.  0.37. What is the ratio of the Aid flow (current US$) in Burundi in 2002 to that in 2006?
Provide a short and direct response. 1.98. What is the ratio of the Aid flow (current US$) in Uzbekistan in 2002 to that in 2006?
Make the answer very short. 0.53. What is the ratio of the Aid flow (current US$) in Upper middle income in 2003 to that in 2004?
Provide a short and direct response. 0.87. What is the ratio of the Aid flow (current US$) in Bosnia and Herzegovina in 2003 to that in 2004?
Provide a succinct answer. 0.82. What is the ratio of the Aid flow (current US$) of Burundi in 2003 to that in 2004?
Offer a terse response. 1.72. What is the ratio of the Aid flow (current US$) in Uzbekistan in 2003 to that in 2004?
Ensure brevity in your answer.  1.19. What is the ratio of the Aid flow (current US$) in Upper middle income in 2003 to that in 2005?
Your answer should be compact. 0.11. What is the ratio of the Aid flow (current US$) of Bosnia and Herzegovina in 2003 to that in 2005?
Keep it short and to the point. 0.59. What is the ratio of the Aid flow (current US$) in Burundi in 2003 to that in 2005?
Keep it short and to the point. 1.05. What is the ratio of the Aid flow (current US$) of Uzbekistan in 2003 to that in 2005?
Give a very brief answer. 1.07. What is the ratio of the Aid flow (current US$) of Upper middle income in 2003 to that in 2006?
Your response must be concise. 0.28. What is the ratio of the Aid flow (current US$) in Bosnia and Herzegovina in 2003 to that in 2006?
Your response must be concise. 0.52. What is the ratio of the Aid flow (current US$) in Burundi in 2003 to that in 2006?
Provide a succinct answer. 2.58. What is the ratio of the Aid flow (current US$) in Uzbekistan in 2003 to that in 2006?
Your answer should be compact. 0.8. What is the ratio of the Aid flow (current US$) of Upper middle income in 2004 to that in 2005?
Ensure brevity in your answer.  0.13. What is the ratio of the Aid flow (current US$) in Bosnia and Herzegovina in 2004 to that in 2005?
Give a very brief answer. 0.72. What is the ratio of the Aid flow (current US$) in Burundi in 2004 to that in 2005?
Ensure brevity in your answer.  0.61. What is the ratio of the Aid flow (current US$) of Upper middle income in 2004 to that in 2006?
Your answer should be compact. 0.32. What is the ratio of the Aid flow (current US$) of Bosnia and Herzegovina in 2004 to that in 2006?
Your response must be concise. 0.64. What is the ratio of the Aid flow (current US$) in Uzbekistan in 2004 to that in 2006?
Offer a very short reply. 0.68. What is the ratio of the Aid flow (current US$) of Upper middle income in 2005 to that in 2006?
Your response must be concise. 2.47. What is the ratio of the Aid flow (current US$) of Bosnia and Herzegovina in 2005 to that in 2006?
Offer a terse response. 0.89. What is the ratio of the Aid flow (current US$) in Burundi in 2005 to that in 2006?
Offer a terse response. 2.46. What is the ratio of the Aid flow (current US$) of Uzbekistan in 2005 to that in 2006?
Keep it short and to the point. 0.75. What is the difference between the highest and the second highest Aid flow (current US$) in Upper middle income?
Keep it short and to the point. 5.52e+08. What is the difference between the highest and the second highest Aid flow (current US$) of Bosnia and Herzegovina?
Keep it short and to the point. 3.14e+06. What is the difference between the highest and the lowest Aid flow (current US$) of Upper middle income?
Your answer should be very brief. 8.37e+08. What is the difference between the highest and the lowest Aid flow (current US$) in Bosnia and Herzegovina?
Keep it short and to the point. 1.82e+07. What is the difference between the highest and the lowest Aid flow (current US$) in Burundi?
Your answer should be compact. 7.60e+05. What is the difference between the highest and the lowest Aid flow (current US$) of Uzbekistan?
Offer a very short reply. 3.50e+05. 